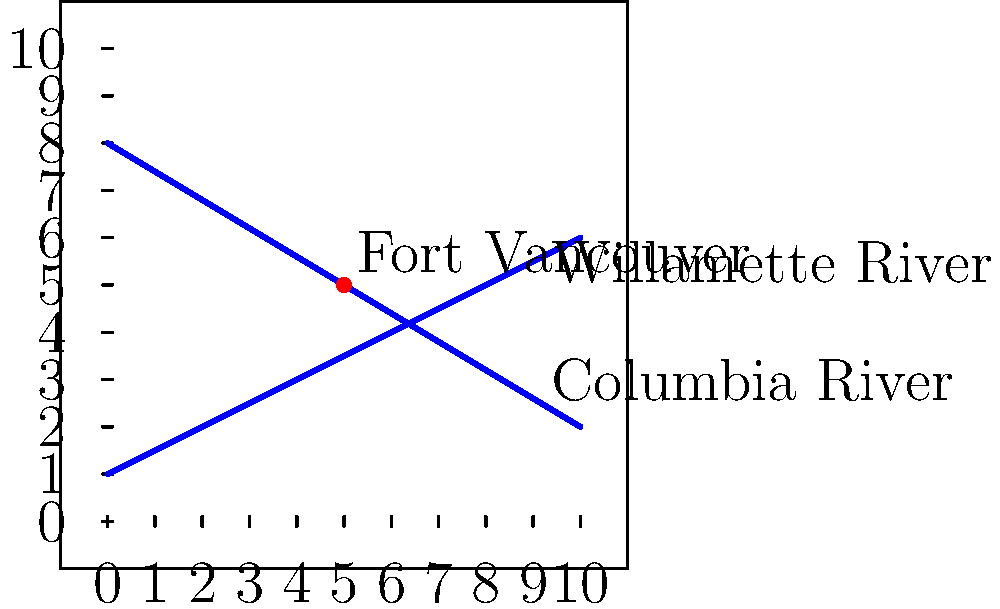In the early 19th century, Fort Vancouver was established near the confluence of two major rivers in the Pacific Northwest. On the given coordinate system, the Columbia River is represented by the line equation $y = -\frac{3}{5}x + 8$, and the Willamette River by $y = \frac{1}{2}x + 1$. Determine the coordinates of Fort Vancouver, which is located at the intersection of these two rivers. To find the intersection point of the two rivers, we need to solve the system of equations:

1) Columbia River: $y = -\frac{3}{5}x + 8$
2) Willamette River: $y = \frac{1}{2}x + 1$

Step 1: Set the equations equal to each other since the y-coordinates are the same at the intersection point.
$$-\frac{3}{5}x + 8 = \frac{1}{2}x + 1$$

Step 2: Solve for x by first subtracting $\frac{1}{2}x$ from both sides.
$$-\frac{3}{5}x - \frac{1}{2}x + 8 = 1$$
$$-\frac{11}{10}x + 8 = 1$$

Step 3: Subtract 8 from both sides.
$$-\frac{11}{10}x = -7$$

Step 4: Multiply both sides by $-\frac{10}{11}$.
$$x = 5$$

Step 5: Substitute x = 5 into either of the original equations to find y. Let's use the Columbia River equation:
$$y = -\frac{3}{5}(5) + 8 = -3 + 8 = 5$$

Therefore, the intersection point, which represents the location of Fort Vancouver, is at the coordinates (5, 5).
Answer: (5, 5) 